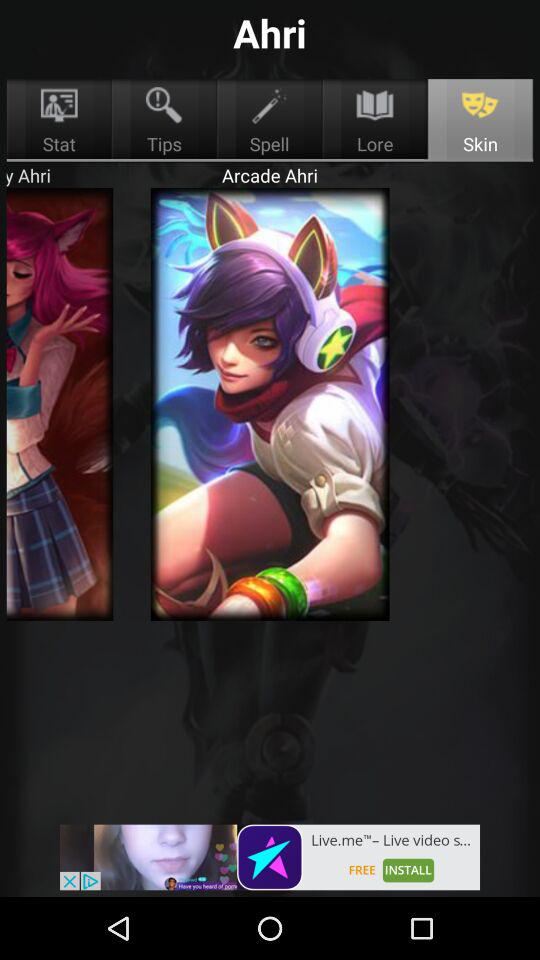Which tab is selected? The selected tab is "Skin". 